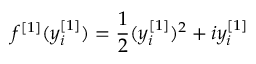Convert formula to latex. <formula><loc_0><loc_0><loc_500><loc_500>f ^ { [ 1 ] } ( y _ { i } ^ { [ 1 ] } ) = \frac { 1 } { 2 } ( y _ { i } ^ { [ 1 ] } ) ^ { 2 } + i y _ { i } ^ { [ 1 ] }</formula> 